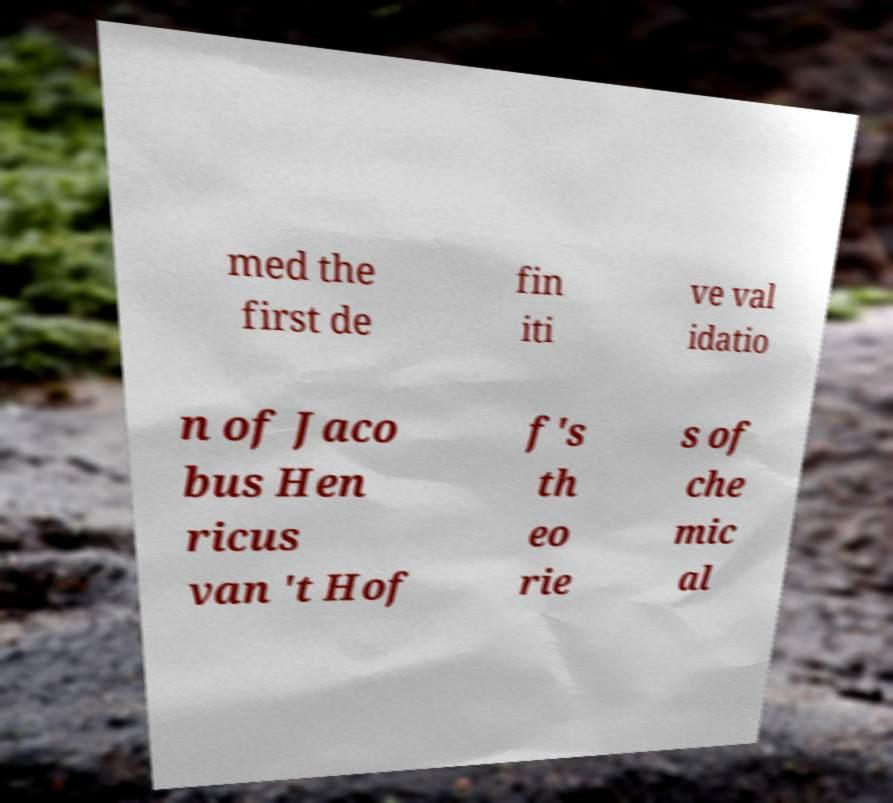Can you read and provide the text displayed in the image?This photo seems to have some interesting text. Can you extract and type it out for me? med the first de fin iti ve val idatio n of Jaco bus Hen ricus van 't Hof f's th eo rie s of che mic al 